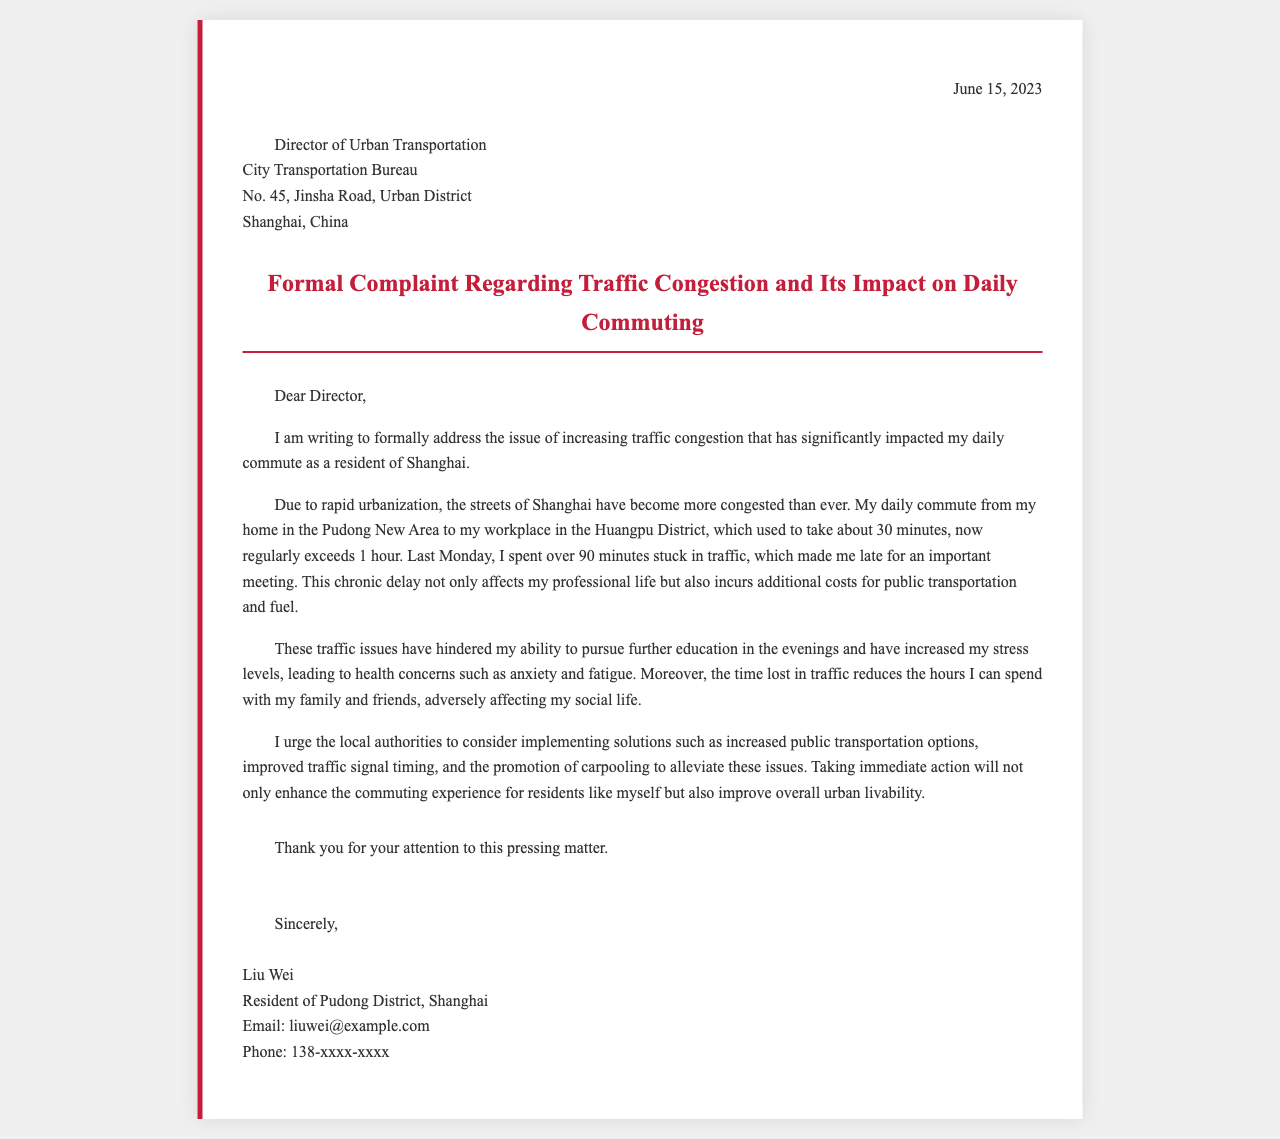what date was the letter written? The date mentioned at the top of the letter indicates when it was composed.
Answer: June 15, 2023 who is the recipient of the letter? The letter specifies the title and the department of the person to whom it is addressed.
Answer: Director of Urban Transportation what city is the complaint regarding? The letter mentions the location of the issue being addressed.
Answer: Shanghai how long did the writer's commute used to take? The document states the original commuting time before congestion increased.
Answer: 30 minutes what is one proposed solution in the letter? The letter provides suggestions to alleviate traffic congestion and improve commuting.
Answer: Increased public transportation options how long did the writer get stuck in traffic last Monday? A specific instance of traffic delay is mentioned in the document.
Answer: 90 minutes what is the sender's name? The document concludes with the name of the person sending the complaint.
Answer: Liu Wei what is one health concern mentioned by the writer? The letter highlights negative impacts of traffic congestion on the writer's health.
Answer: Anxiety what section of the letter outlines the main issue? The paragraph where the writer discusses the impact of traffic congestion can be identified.
Answer: Introduction 